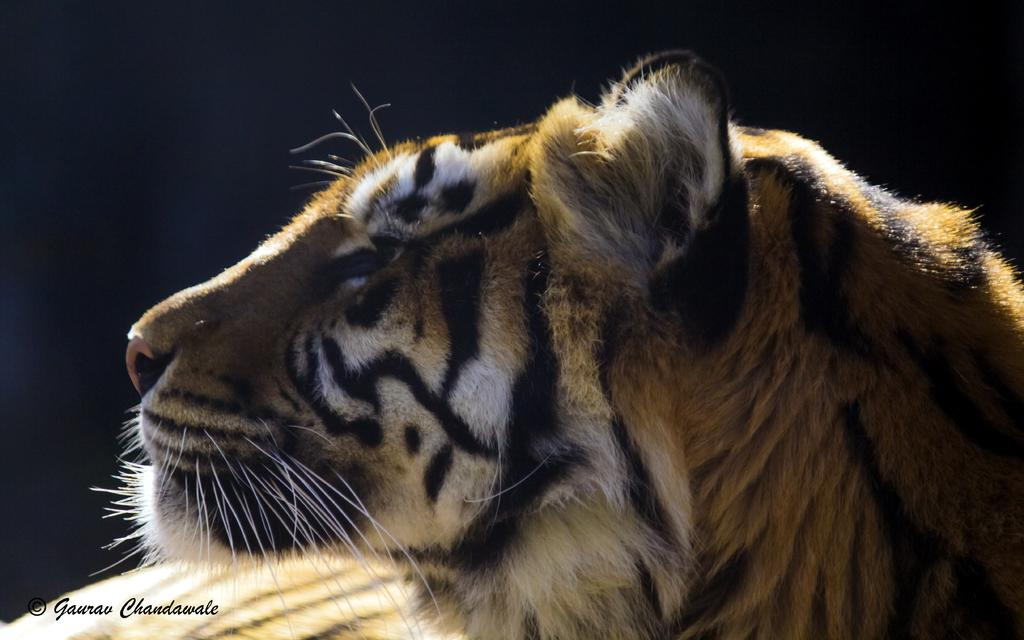What animal is in the image? There is a tiger in the image. What color is the background of the image? The background of the image is black. What type of bird is singing in rhythm in the image? There is no bird or singing in the image; it features a tiger against a black background. 